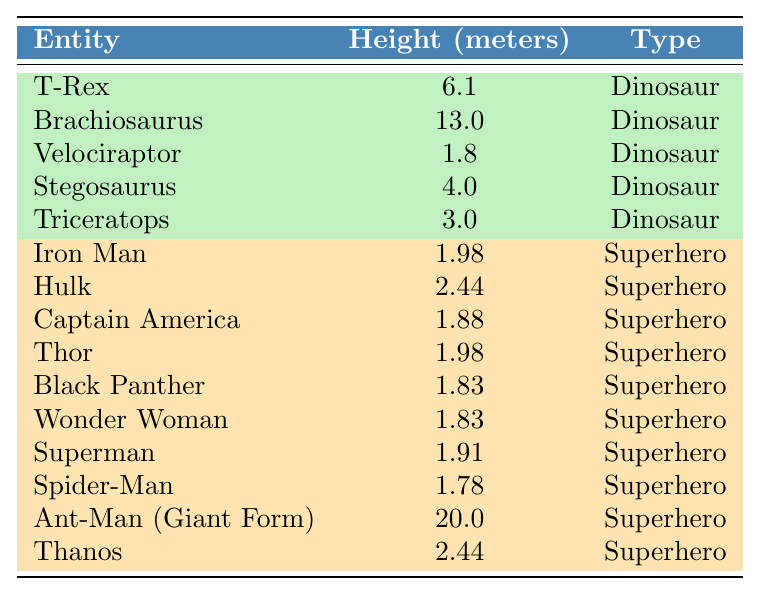What is the height of the Brachiosaurus? The table lists the Brachiosaurus's height as 13.0 meters.
Answer: 13.0 meters Which superhero has the same height as the T-Rex? The T-Rex is 6.1 meters tall, and looking at the superheroes, none match that height.
Answer: No superhero matches T-Rex's height What is the total height of all dinosaurs in the table? The heights of dinosaurs are 6.1 (T-Rex) + 13.0 (Brachiosaurus) + 1.8 (Velociraptor) + 4.0 (Stegosaurus) + 3.0 (Triceratops) = 28.9 meters.
Answer: 28.9 meters How many superheroes are taller than Thor? Thor is 1.98 meters tall. The following superheroes are taller: Ant-Man (20.0 m), Hulk (2.44 m), and Thanos (2.44 m), so there are 3 superheroes taller than Thor.
Answer: 3 superheroes What is the average height of superheroes in the table? The heights of superheroes are: 1.98, 2.44, 1.88, 1.98, 1.83, 1.83, 1.91, 1.78, 20.0, and 2.44 meters. There are 10 superheroes, and their total height is 36.29 meters. The average height is 36.29/10 = 3.629 meters.
Answer: 3.629 meters Is the Hulk taller than the Brachiosaurus? The Brachiosaurus stands at 13.0 meters, while the Hulk is 2.44 meters tall. Therefore, Hulk is not taller than Brachiosaurus.
Answer: No Which dinosaur is the shortest? Among the dinosaurs listed, the Velociraptor at 1.8 meters is the shortest compared to others like T-Rex and Brachiosaurus.
Answer: Velociraptor How much taller is Ant-Man in Giant Form than the tallest dinosaur? The tallest dinosaur is Brachiosaurus at 13.0 meters and Ant-Man in Giant Form is 20.0 meters. The difference in height is 20.0 - 13.0 = 7.0 meters.
Answer: 7.0 meters Which superhero has the closest height to Captain America? Captain America is 1.88 meters tall, and the closest superhero is Iron Man at 1.98 meters, only 0.1 meters taller.
Answer: Iron Man Are there more dinosaurs or superheroes listed in the table? There are 5 dinosaurs and 10 superheroes, which means there are more superheroes than dinosaurs listed.
Answer: More superheroes (10) What is the height difference between the tallest and shortest superhero in the table? The tallest superhero is Ant-Man (20.0 meters) and the shortest is Spider-Man (1.78 meters). The height difference is 20.0 - 1.78 = 18.22 meters.
Answer: 18.22 meters 